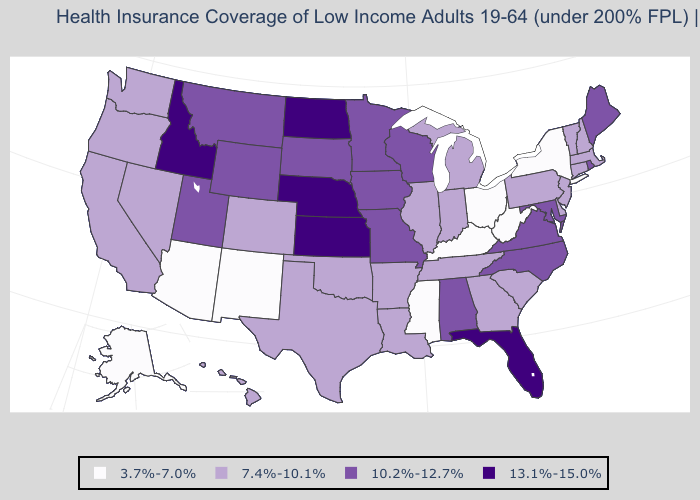Name the states that have a value in the range 3.7%-7.0%?
Short answer required. Alaska, Arizona, Kentucky, Mississippi, New Mexico, New York, Ohio, West Virginia. What is the value of New Mexico?
Be succinct. 3.7%-7.0%. Does Massachusetts have a higher value than New York?
Keep it brief. Yes. What is the lowest value in the West?
Short answer required. 3.7%-7.0%. What is the value of Minnesota?
Be succinct. 10.2%-12.7%. How many symbols are there in the legend?
Concise answer only. 4. Name the states that have a value in the range 13.1%-15.0%?
Short answer required. Florida, Idaho, Kansas, Nebraska, North Dakota. Among the states that border Louisiana , which have the highest value?
Be succinct. Arkansas, Texas. Which states hav the highest value in the West?
Write a very short answer. Idaho. Name the states that have a value in the range 13.1%-15.0%?
Write a very short answer. Florida, Idaho, Kansas, Nebraska, North Dakota. What is the value of Pennsylvania?
Give a very brief answer. 7.4%-10.1%. What is the value of Missouri?
Short answer required. 10.2%-12.7%. Which states hav the highest value in the Northeast?
Concise answer only. Maine, Rhode Island. What is the lowest value in the USA?
Keep it brief. 3.7%-7.0%. What is the value of Arkansas?
Concise answer only. 7.4%-10.1%. 